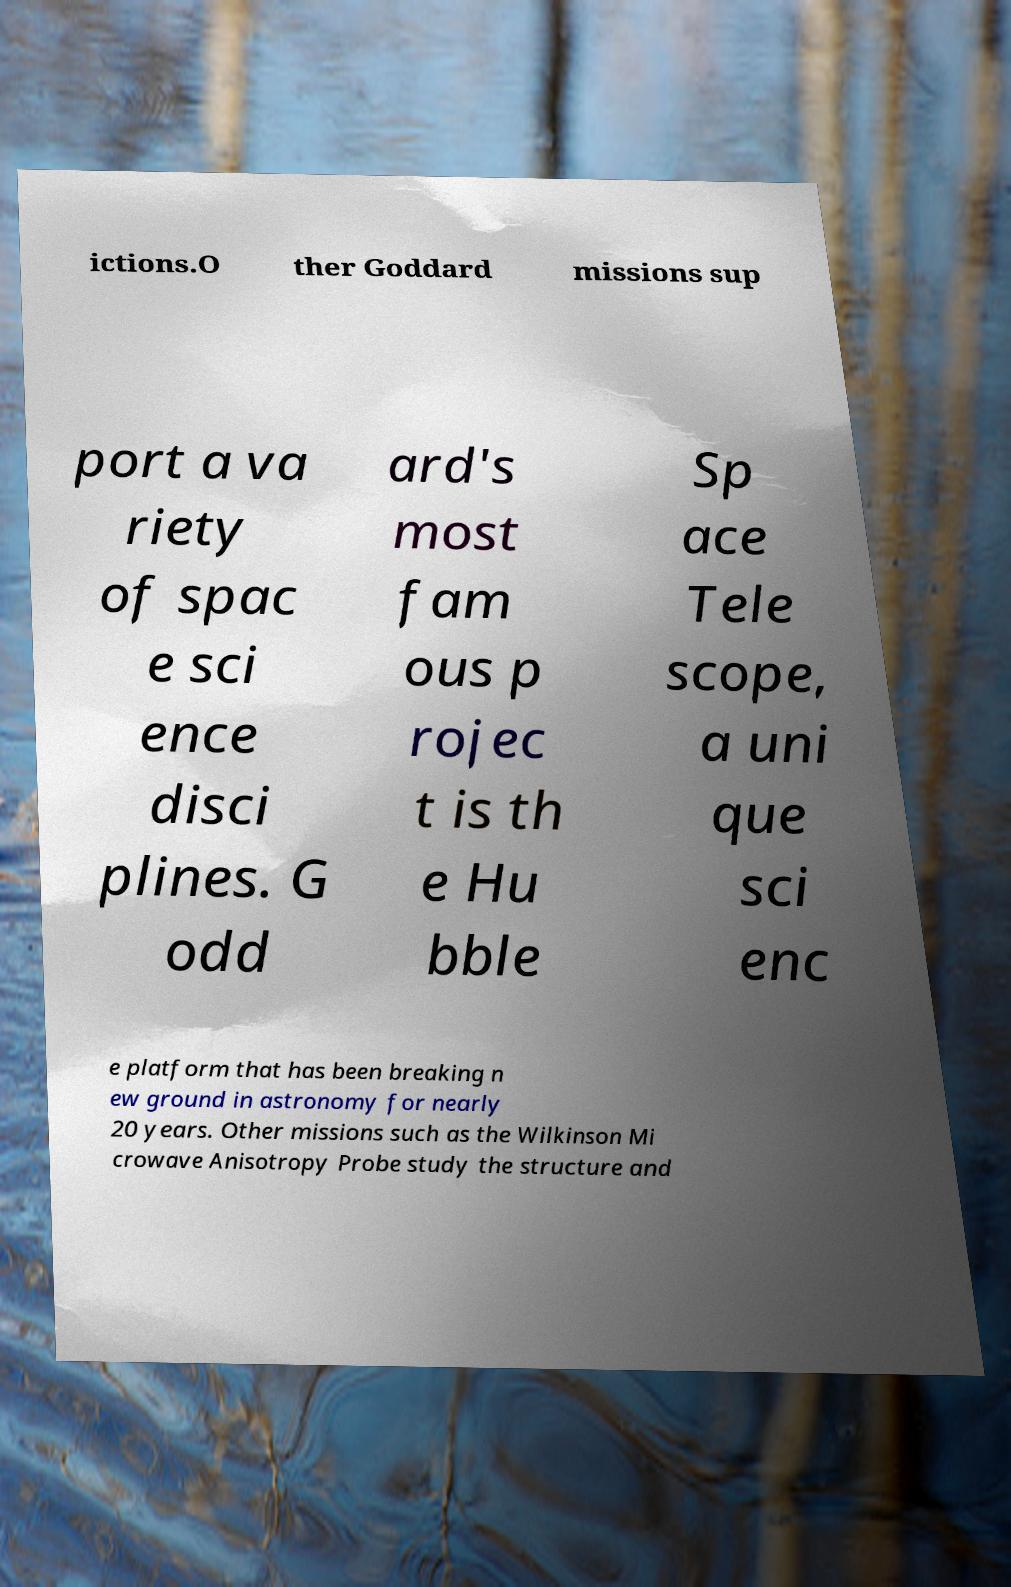There's text embedded in this image that I need extracted. Can you transcribe it verbatim? ictions.O ther Goddard missions sup port a va riety of spac e sci ence disci plines. G odd ard's most fam ous p rojec t is th e Hu bble Sp ace Tele scope, a uni que sci enc e platform that has been breaking n ew ground in astronomy for nearly 20 years. Other missions such as the Wilkinson Mi crowave Anisotropy Probe study the structure and 